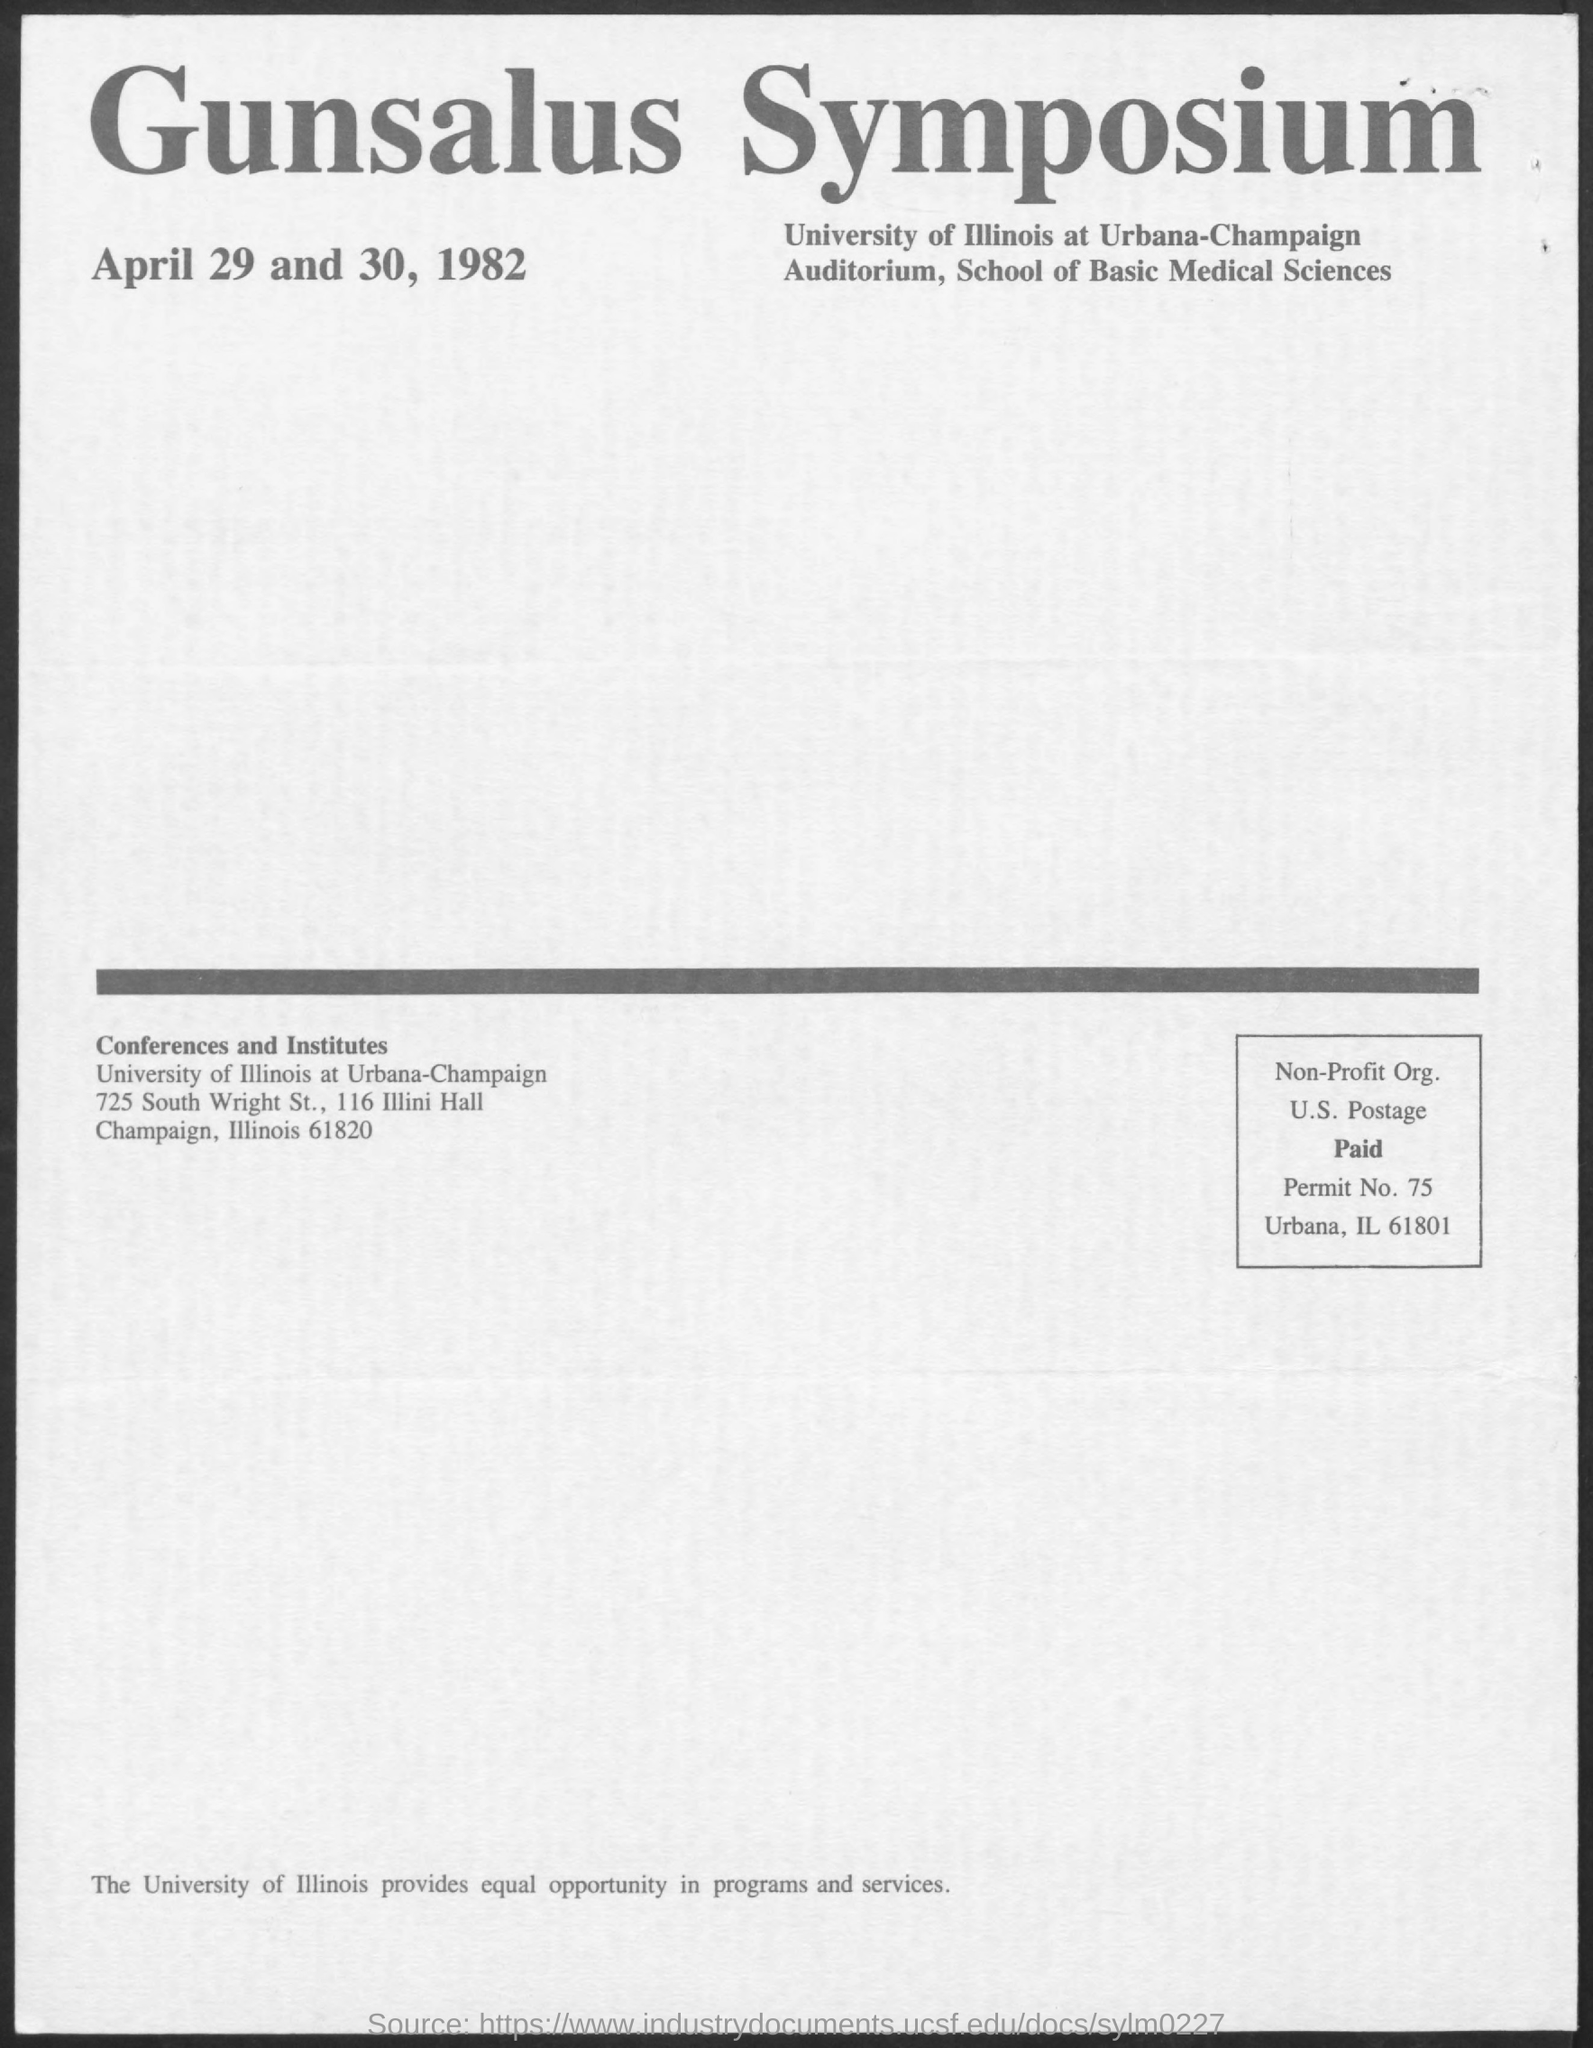What is the Permit No given in this document?
Provide a succinct answer. 75. 